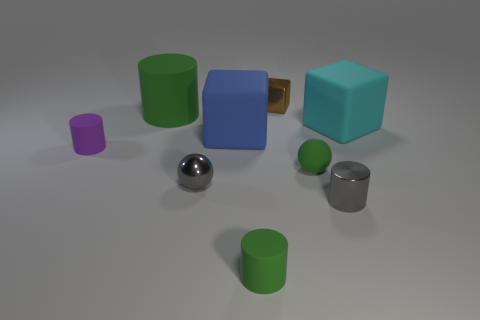How many green cylinders must be subtracted to get 1 green cylinders? 1 Subtract all cyan spheres. How many green cylinders are left? 2 Subtract all small purple matte cylinders. How many cylinders are left? 3 Subtract all purple cylinders. How many cylinders are left? 3 Subtract all cyan cylinders. Subtract all brown cubes. How many cylinders are left? 4 Add 1 cyan matte balls. How many objects exist? 10 Subtract all spheres. How many objects are left? 7 Add 8 small green spheres. How many small green spheres exist? 9 Subtract 0 red spheres. How many objects are left? 9 Subtract all tiny gray spheres. Subtract all gray metal cylinders. How many objects are left? 7 